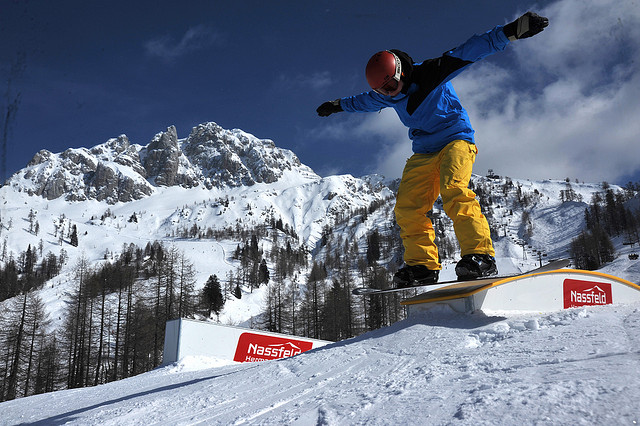Can you provide some background knowledge about snowboarding? Certainly. Snowboarding is a popular winter sport that involves descending a snow-covered slope while standing on a snowboard, which is a flat board with special bindings to secure the rider's feet. Inspired by skateboarding, surfing, and skiing, it gained significant popularity in the late 20th century. Snowboarders often perform various tricks and jumps, and there are different styles of snowboarding such as freestyle, freeride, and alpine. The sport can be practiced in snow parks, on groomed runs (pistes), or in backcountry areas. Snowboarding has also become an Olympic sport, with events including the halfpipe and slopestyle. 